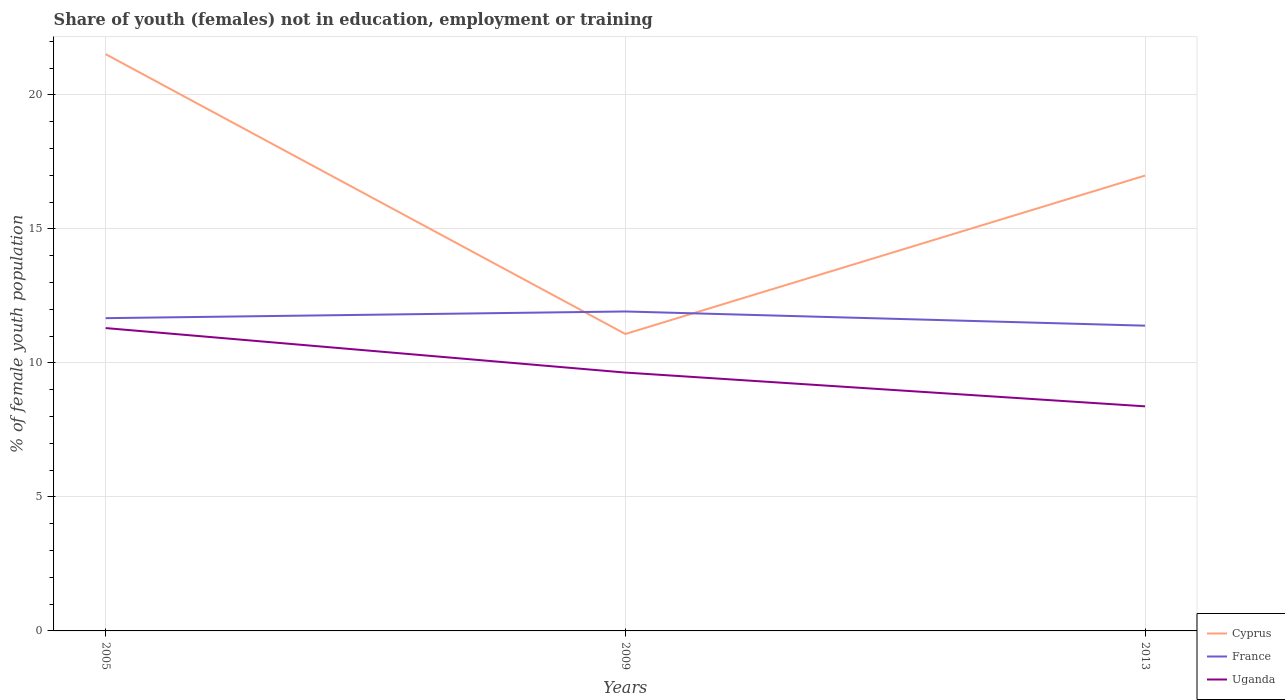Is the number of lines equal to the number of legend labels?
Your response must be concise. Yes. Across all years, what is the maximum percentage of unemployed female population in in Uganda?
Give a very brief answer. 8.38. In which year was the percentage of unemployed female population in in France maximum?
Your answer should be compact. 2013. What is the total percentage of unemployed female population in in Uganda in the graph?
Offer a terse response. 2.92. What is the difference between the highest and the second highest percentage of unemployed female population in in France?
Make the answer very short. 0.53. How many years are there in the graph?
Offer a terse response. 3. What is the difference between two consecutive major ticks on the Y-axis?
Provide a succinct answer. 5. Are the values on the major ticks of Y-axis written in scientific E-notation?
Provide a succinct answer. No. How many legend labels are there?
Provide a short and direct response. 3. What is the title of the graph?
Provide a succinct answer. Share of youth (females) not in education, employment or training. Does "Monaco" appear as one of the legend labels in the graph?
Make the answer very short. No. What is the label or title of the X-axis?
Your response must be concise. Years. What is the label or title of the Y-axis?
Ensure brevity in your answer.  % of female youth population. What is the % of female youth population of Cyprus in 2005?
Give a very brief answer. 21.52. What is the % of female youth population in France in 2005?
Your response must be concise. 11.67. What is the % of female youth population of Uganda in 2005?
Provide a short and direct response. 11.3. What is the % of female youth population of Cyprus in 2009?
Your response must be concise. 11.08. What is the % of female youth population in France in 2009?
Keep it short and to the point. 11.92. What is the % of female youth population of Uganda in 2009?
Keep it short and to the point. 9.64. What is the % of female youth population of Cyprus in 2013?
Offer a very short reply. 16.99. What is the % of female youth population in France in 2013?
Make the answer very short. 11.39. What is the % of female youth population of Uganda in 2013?
Provide a short and direct response. 8.38. Across all years, what is the maximum % of female youth population in Cyprus?
Give a very brief answer. 21.52. Across all years, what is the maximum % of female youth population of France?
Make the answer very short. 11.92. Across all years, what is the maximum % of female youth population in Uganda?
Make the answer very short. 11.3. Across all years, what is the minimum % of female youth population in Cyprus?
Ensure brevity in your answer.  11.08. Across all years, what is the minimum % of female youth population of France?
Keep it short and to the point. 11.39. Across all years, what is the minimum % of female youth population in Uganda?
Ensure brevity in your answer.  8.38. What is the total % of female youth population in Cyprus in the graph?
Provide a short and direct response. 49.59. What is the total % of female youth population of France in the graph?
Offer a very short reply. 34.98. What is the total % of female youth population of Uganda in the graph?
Ensure brevity in your answer.  29.32. What is the difference between the % of female youth population in Cyprus in 2005 and that in 2009?
Provide a succinct answer. 10.44. What is the difference between the % of female youth population in Uganda in 2005 and that in 2009?
Your response must be concise. 1.66. What is the difference between the % of female youth population of Cyprus in 2005 and that in 2013?
Offer a very short reply. 4.53. What is the difference between the % of female youth population in France in 2005 and that in 2013?
Provide a short and direct response. 0.28. What is the difference between the % of female youth population of Uganda in 2005 and that in 2013?
Keep it short and to the point. 2.92. What is the difference between the % of female youth population in Cyprus in 2009 and that in 2013?
Give a very brief answer. -5.91. What is the difference between the % of female youth population of France in 2009 and that in 2013?
Provide a short and direct response. 0.53. What is the difference between the % of female youth population in Uganda in 2009 and that in 2013?
Offer a very short reply. 1.26. What is the difference between the % of female youth population of Cyprus in 2005 and the % of female youth population of France in 2009?
Keep it short and to the point. 9.6. What is the difference between the % of female youth population of Cyprus in 2005 and the % of female youth population of Uganda in 2009?
Make the answer very short. 11.88. What is the difference between the % of female youth population of France in 2005 and the % of female youth population of Uganda in 2009?
Provide a short and direct response. 2.03. What is the difference between the % of female youth population in Cyprus in 2005 and the % of female youth population in France in 2013?
Your response must be concise. 10.13. What is the difference between the % of female youth population of Cyprus in 2005 and the % of female youth population of Uganda in 2013?
Give a very brief answer. 13.14. What is the difference between the % of female youth population of France in 2005 and the % of female youth population of Uganda in 2013?
Make the answer very short. 3.29. What is the difference between the % of female youth population in Cyprus in 2009 and the % of female youth population in France in 2013?
Your response must be concise. -0.31. What is the difference between the % of female youth population of France in 2009 and the % of female youth population of Uganda in 2013?
Make the answer very short. 3.54. What is the average % of female youth population of Cyprus per year?
Give a very brief answer. 16.53. What is the average % of female youth population of France per year?
Offer a terse response. 11.66. What is the average % of female youth population of Uganda per year?
Provide a succinct answer. 9.77. In the year 2005, what is the difference between the % of female youth population of Cyprus and % of female youth population of France?
Provide a succinct answer. 9.85. In the year 2005, what is the difference between the % of female youth population of Cyprus and % of female youth population of Uganda?
Provide a succinct answer. 10.22. In the year 2005, what is the difference between the % of female youth population in France and % of female youth population in Uganda?
Your response must be concise. 0.37. In the year 2009, what is the difference between the % of female youth population in Cyprus and % of female youth population in France?
Ensure brevity in your answer.  -0.84. In the year 2009, what is the difference between the % of female youth population of Cyprus and % of female youth population of Uganda?
Your answer should be very brief. 1.44. In the year 2009, what is the difference between the % of female youth population in France and % of female youth population in Uganda?
Your answer should be very brief. 2.28. In the year 2013, what is the difference between the % of female youth population of Cyprus and % of female youth population of France?
Ensure brevity in your answer.  5.6. In the year 2013, what is the difference between the % of female youth population in Cyprus and % of female youth population in Uganda?
Your response must be concise. 8.61. In the year 2013, what is the difference between the % of female youth population in France and % of female youth population in Uganda?
Your answer should be compact. 3.01. What is the ratio of the % of female youth population in Cyprus in 2005 to that in 2009?
Offer a terse response. 1.94. What is the ratio of the % of female youth population of Uganda in 2005 to that in 2009?
Give a very brief answer. 1.17. What is the ratio of the % of female youth population in Cyprus in 2005 to that in 2013?
Ensure brevity in your answer.  1.27. What is the ratio of the % of female youth population of France in 2005 to that in 2013?
Provide a short and direct response. 1.02. What is the ratio of the % of female youth population in Uganda in 2005 to that in 2013?
Make the answer very short. 1.35. What is the ratio of the % of female youth population of Cyprus in 2009 to that in 2013?
Provide a succinct answer. 0.65. What is the ratio of the % of female youth population of France in 2009 to that in 2013?
Offer a very short reply. 1.05. What is the ratio of the % of female youth population of Uganda in 2009 to that in 2013?
Provide a short and direct response. 1.15. What is the difference between the highest and the second highest % of female youth population in Cyprus?
Give a very brief answer. 4.53. What is the difference between the highest and the second highest % of female youth population of Uganda?
Offer a very short reply. 1.66. What is the difference between the highest and the lowest % of female youth population in Cyprus?
Your response must be concise. 10.44. What is the difference between the highest and the lowest % of female youth population in France?
Ensure brevity in your answer.  0.53. What is the difference between the highest and the lowest % of female youth population in Uganda?
Give a very brief answer. 2.92. 